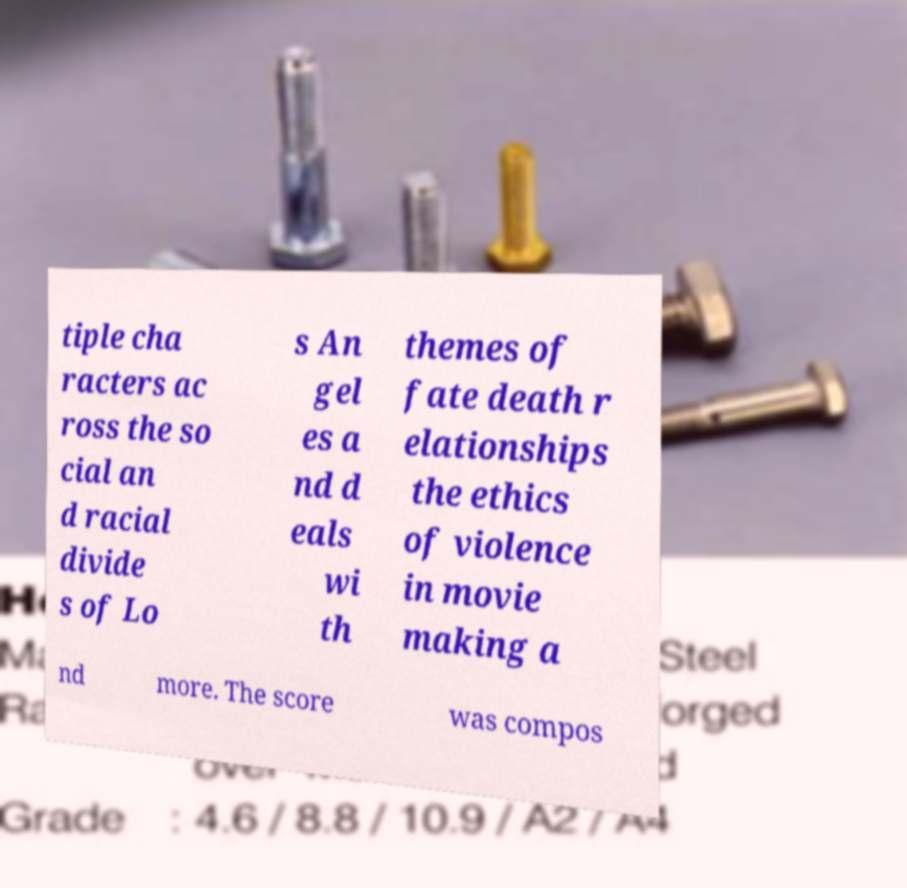Can you read and provide the text displayed in the image?This photo seems to have some interesting text. Can you extract and type it out for me? tiple cha racters ac ross the so cial an d racial divide s of Lo s An gel es a nd d eals wi th themes of fate death r elationships the ethics of violence in movie making a nd more. The score was compos 